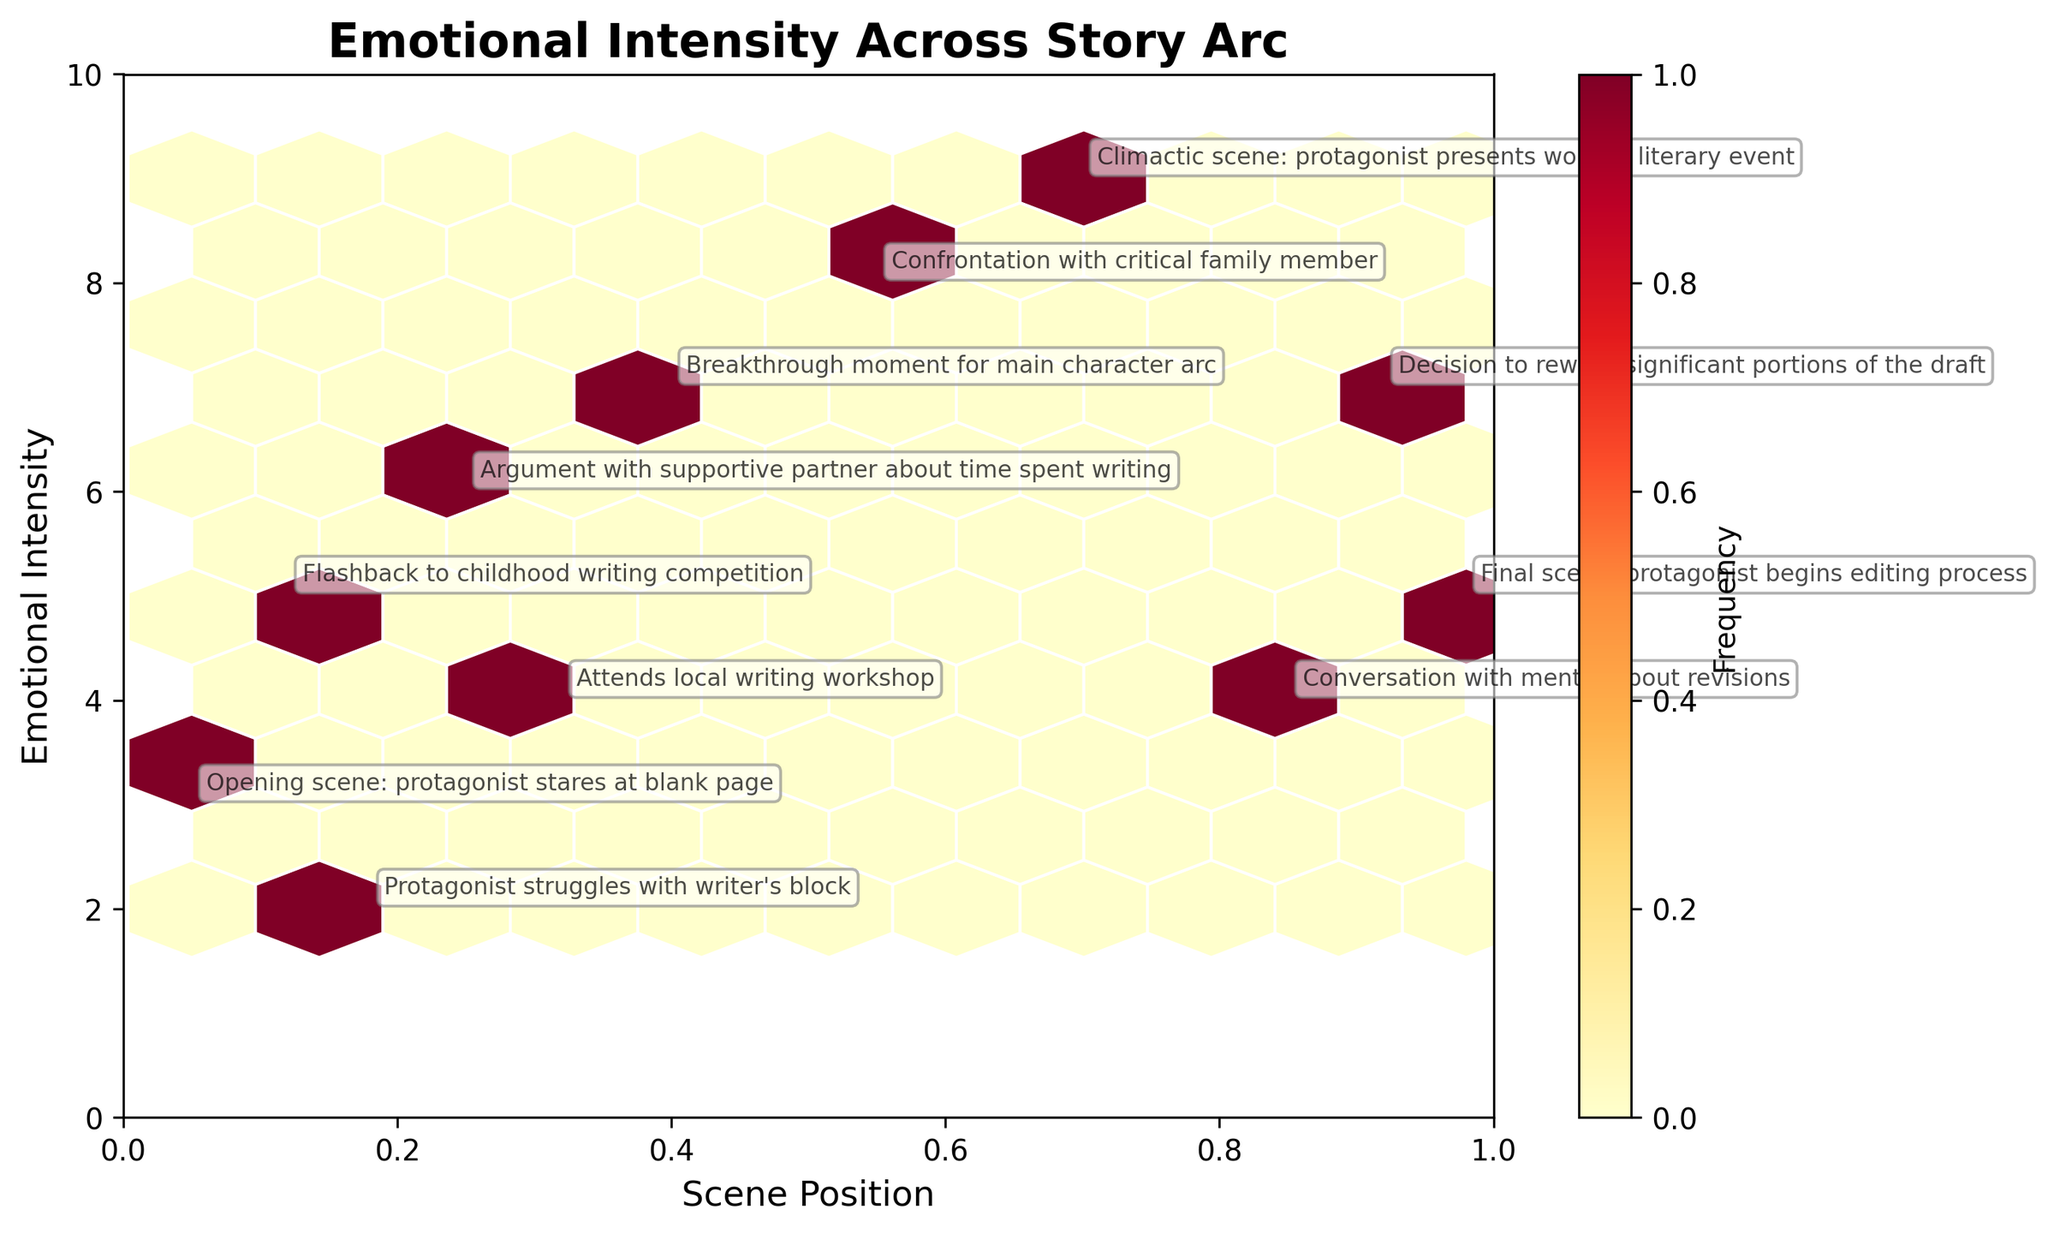What's the title of the plot? The title is usually placed at the top of the plot, so by looking at the top, we can identify the title of the figure.
Answer: Emotional Intensity Across Story Arc What are the labels on the x and y axes? By examining the x and y axes, we can see the labels provided for each axis. The labels are written beside the respective axes.
Answer: Scene Position and Emotional Intensity How many scenes have an emotional intensity greater than 6? We need to count the number of data points (or hexagons with annotations) that have an emotional intensity value greater than 6.
Answer: 4 What is the emotional intensity of the scene at the literary event? Locate the description "Climactic scene: protagonist presents work at literary event" in the plot and check the corresponding emotional intensity.
Answer: 9 What is the average emotional intensity of scenes occurring after the midpoint of the story arc (scene position > 0.5)? Identify scenes with positions greater than 0.5, and then calculate the average of the emotional intensities for these scenes. The scenes are at 0.55 (8), 0.70 (9), 0.85 (4), 0.92 (7), 0.98 (5). Calculate (8+9+4+7+5)/5.
Answer: 6.6 Which scene has the lowest emotional intensity, and what is its description? Look for the lowest point on the y-axis that has an annotation and check the corresponding description.
Answer: Protagonist struggles with writer's block Compare the emotional intensities of the opening scene and the final scene. Which is higher? Find the emotional intensities for the opening scene (3) and the final scene (5) from their annotations and compare them.
Answer: Final scene What color represents the highest frequency of occurrences on the hexbin plot? Check the color of the hexagons and refer to the color bar to see which color corresponds to areas of highest frequency.
Answer: Dark Red What is the emotional intensity of the scene where the protagonist decides to rewrite significant portions of the draft? Locate the description "Decision to rewrite significant portions of the draft" and identify the corresponding emotional intensity on the y-axis.
Answer: 7 